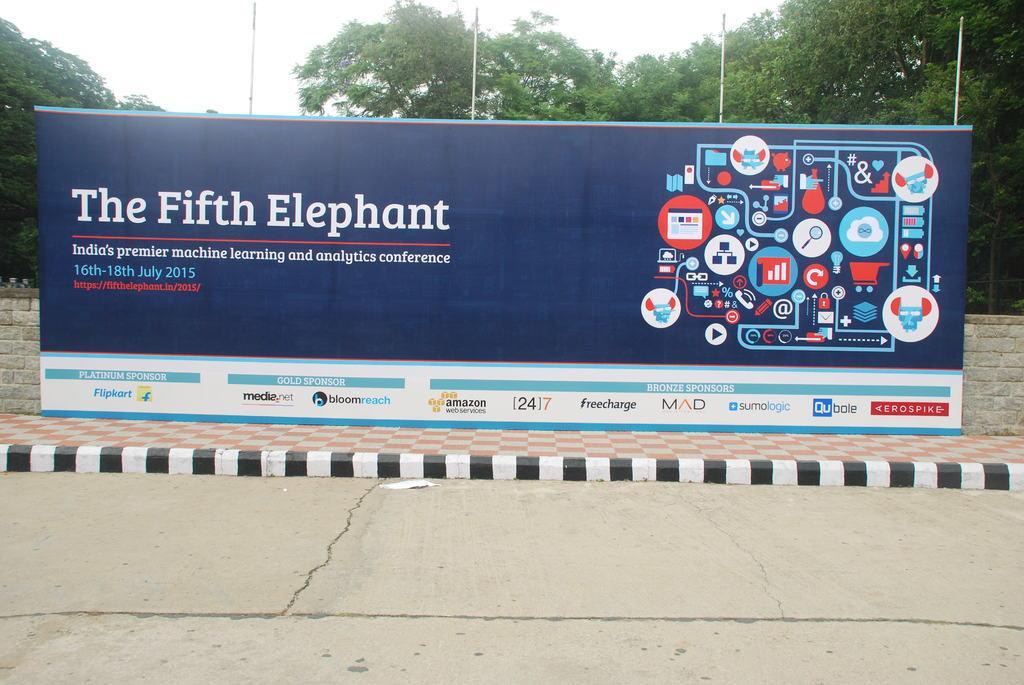Describe this image in one or two sentences. There is a banner kept beside the footpath in front of a wall and it is written as "THE FIFTH ELEPHANT" on the poster. In the background there are plenty of trees and few poles. 